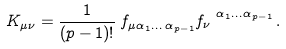<formula> <loc_0><loc_0><loc_500><loc_500>K _ { \mu \nu } = \frac { 1 } { ( p - 1 ) ! } \, f _ { \mu \alpha _ { 1 } \dots \, \alpha _ { p - 1 } } f _ { \nu } ^ { \ \alpha _ { 1 } \dots \alpha _ { p - 1 } } \, .</formula> 